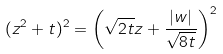<formula> <loc_0><loc_0><loc_500><loc_500>( z ^ { 2 } + t ) ^ { 2 } = \left ( \sqrt { 2 t } z + \frac { | w | } { \sqrt { 8 t } } \right ) ^ { 2 }</formula> 